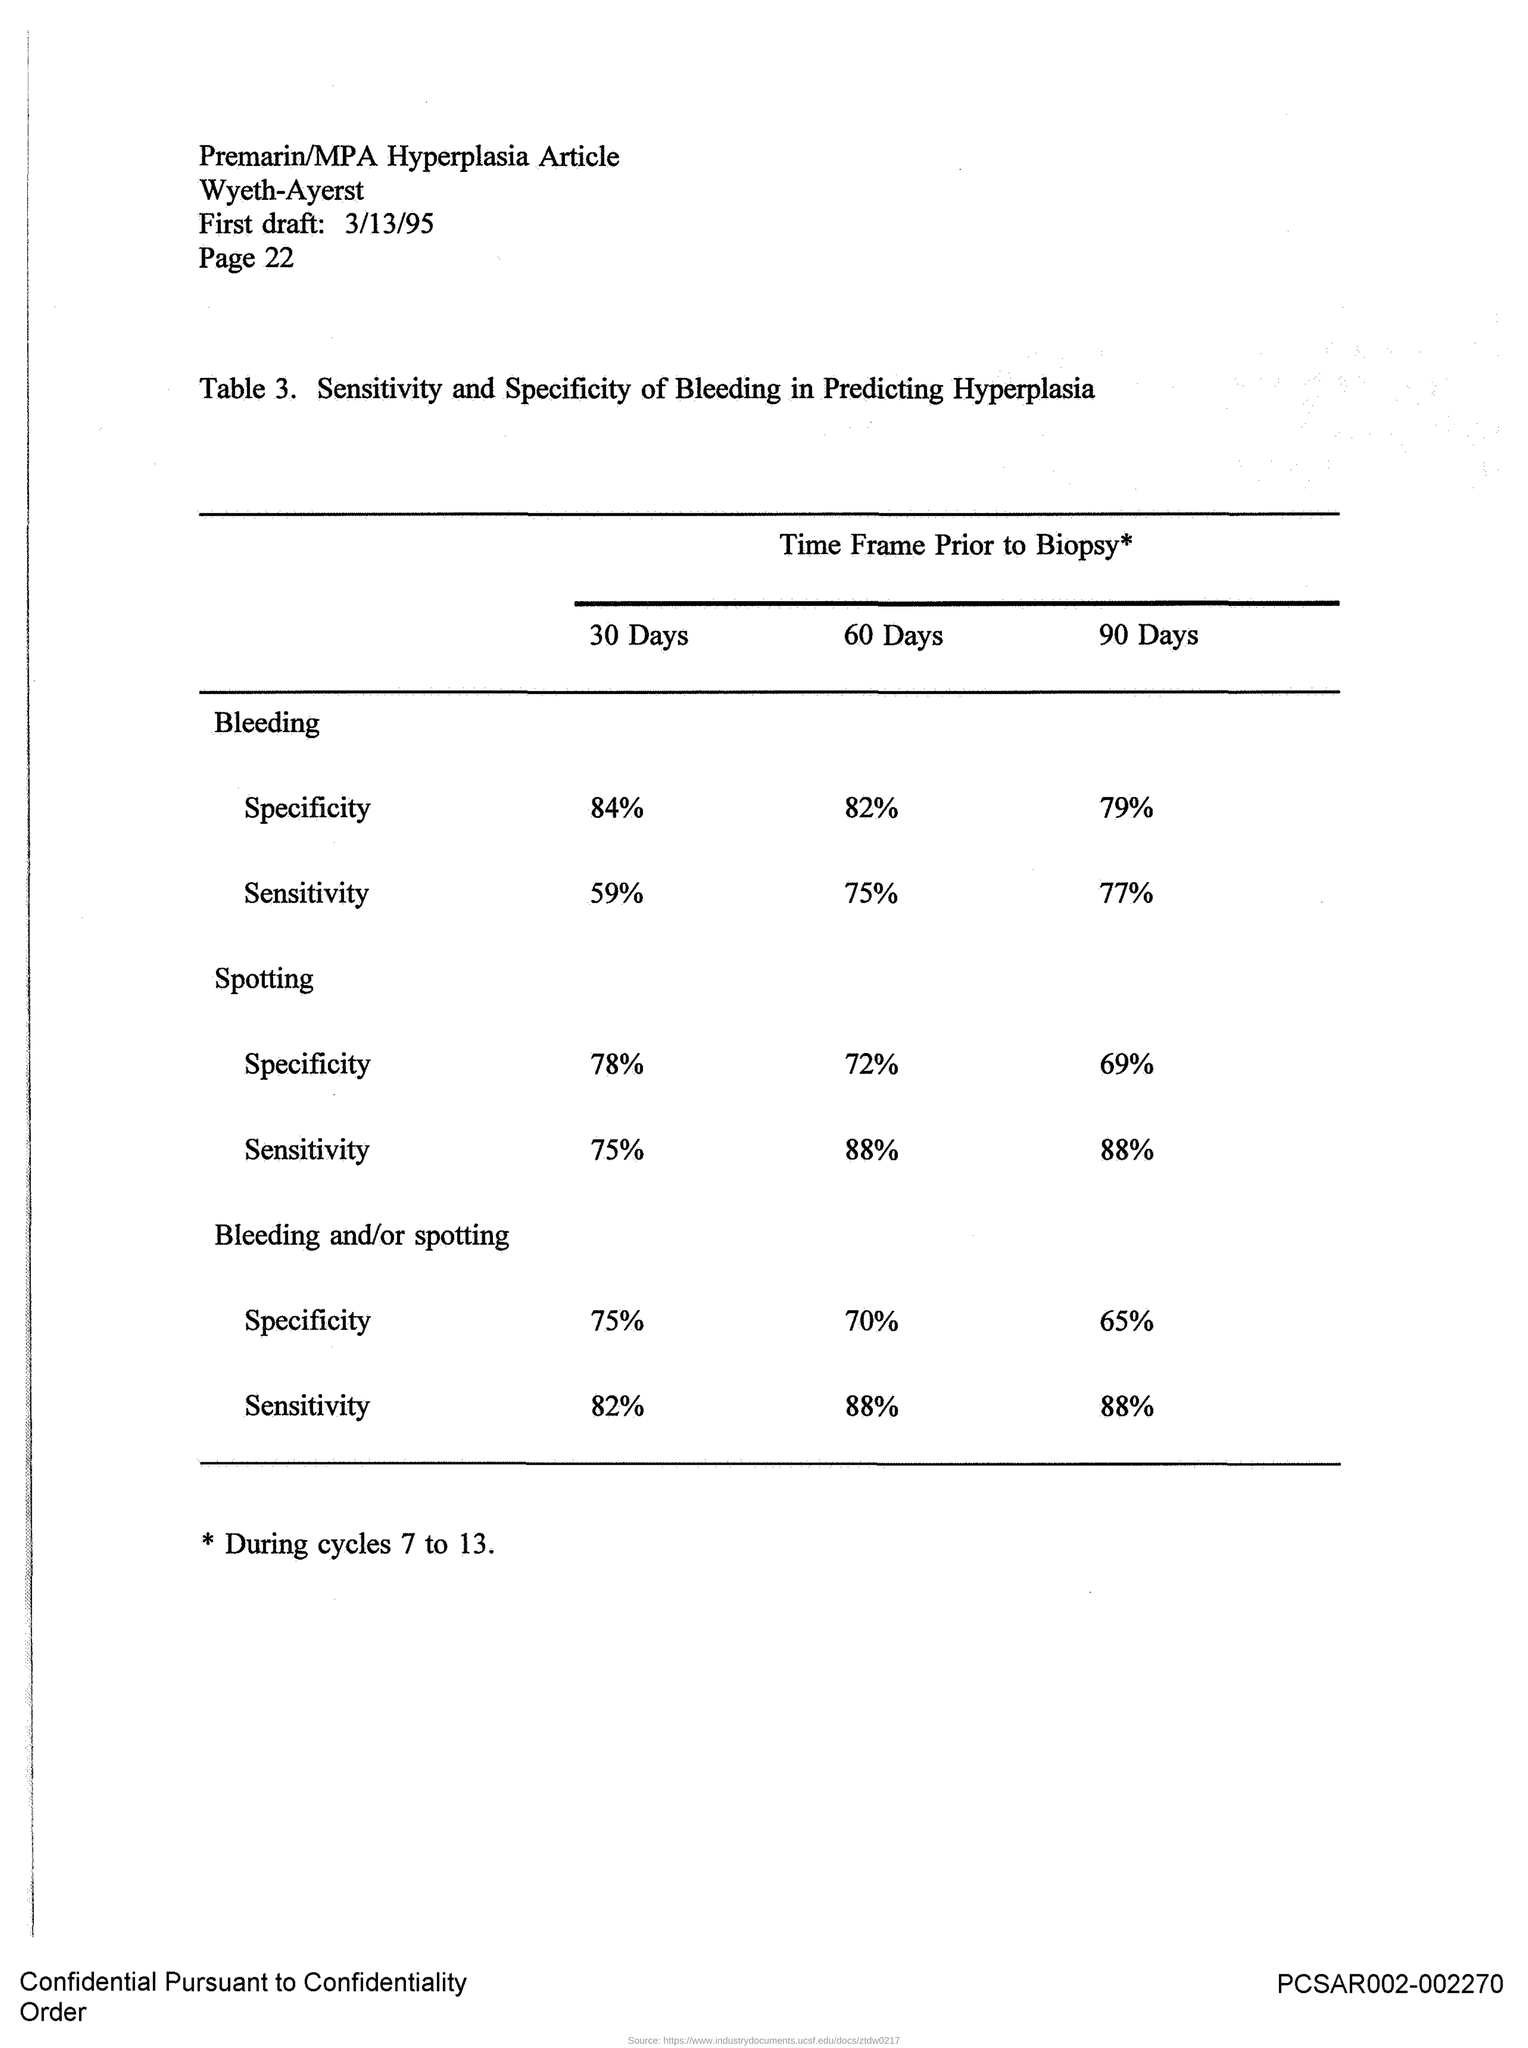Indicate a few pertinent items in this graphic. The first draft is scheduled for March 13, 1995. The page is 22. 